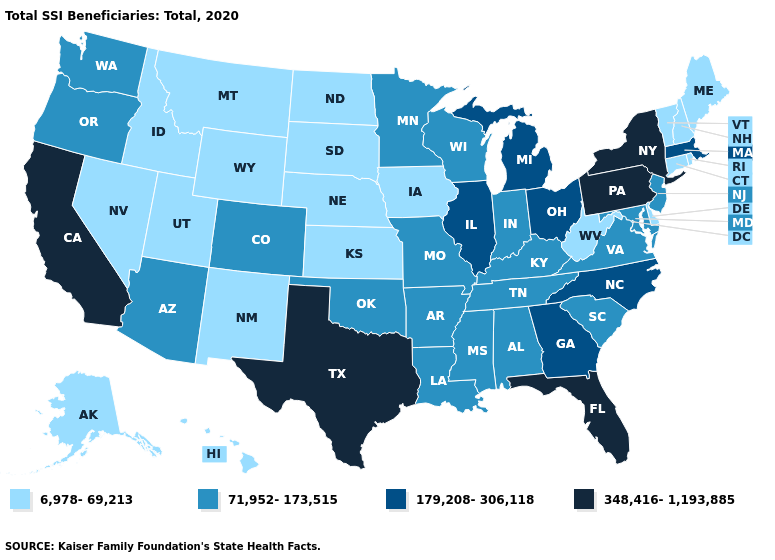Which states hav the highest value in the South?
Quick response, please. Florida, Texas. Which states hav the highest value in the MidWest?
Concise answer only. Illinois, Michigan, Ohio. What is the value of West Virginia?
Be succinct. 6,978-69,213. Does Vermont have a higher value than New York?
Write a very short answer. No. Does North Carolina have the lowest value in the USA?
Keep it brief. No. Among the states that border Illinois , does Wisconsin have the lowest value?
Keep it brief. No. Name the states that have a value in the range 6,978-69,213?
Write a very short answer. Alaska, Connecticut, Delaware, Hawaii, Idaho, Iowa, Kansas, Maine, Montana, Nebraska, Nevada, New Hampshire, New Mexico, North Dakota, Rhode Island, South Dakota, Utah, Vermont, West Virginia, Wyoming. Is the legend a continuous bar?
Quick response, please. No. Name the states that have a value in the range 6,978-69,213?
Quick response, please. Alaska, Connecticut, Delaware, Hawaii, Idaho, Iowa, Kansas, Maine, Montana, Nebraska, Nevada, New Hampshire, New Mexico, North Dakota, Rhode Island, South Dakota, Utah, Vermont, West Virginia, Wyoming. Name the states that have a value in the range 179,208-306,118?
Be succinct. Georgia, Illinois, Massachusetts, Michigan, North Carolina, Ohio. Name the states that have a value in the range 71,952-173,515?
Give a very brief answer. Alabama, Arizona, Arkansas, Colorado, Indiana, Kentucky, Louisiana, Maryland, Minnesota, Mississippi, Missouri, New Jersey, Oklahoma, Oregon, South Carolina, Tennessee, Virginia, Washington, Wisconsin. What is the value of Maine?
Answer briefly. 6,978-69,213. Among the states that border Colorado , does Nebraska have the lowest value?
Write a very short answer. Yes. What is the value of Nevada?
Write a very short answer. 6,978-69,213. 